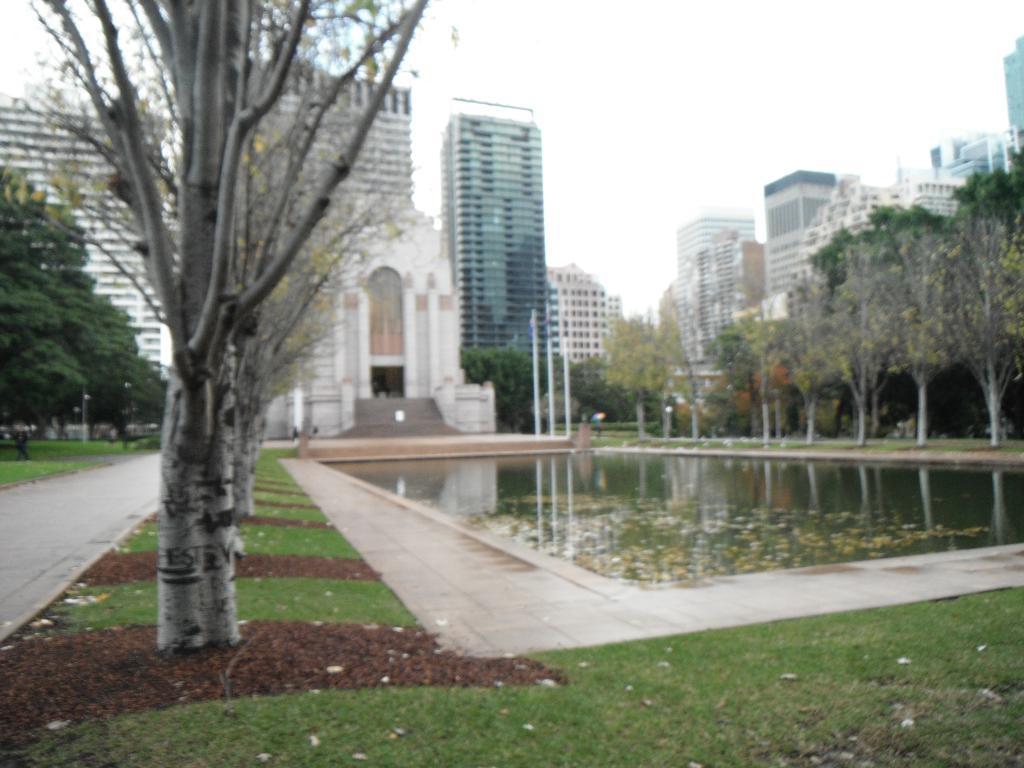In one or two sentences, can you explain what this image depicts? In this picture I can see water, there are trees, poles, there is grass, there are buildings, and in the background there is the sky. 